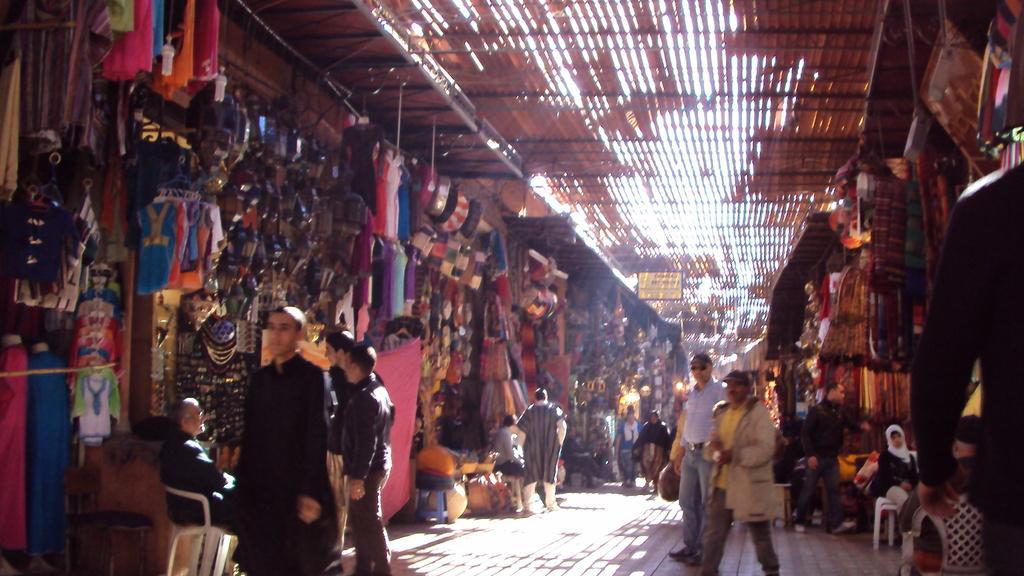In one or two sentences, can you explain what this image depicts? The picture is taken in a street market. There are many shops on both sides. Many people are there on the street. Few are sitting on chairs. In the shop there are clothes, bags and few other things are there. 